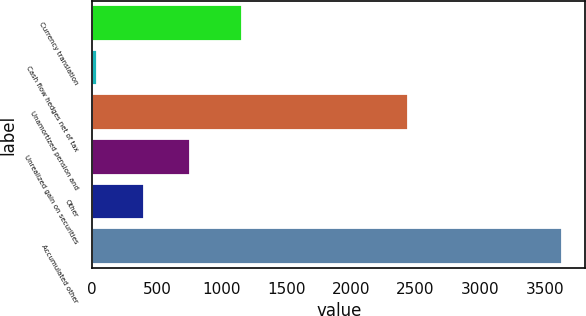<chart> <loc_0><loc_0><loc_500><loc_500><bar_chart><fcel>Currency translation<fcel>Cash flow hedges net of tax<fcel>Unamortized pension and<fcel>Unrealized gain on securities<fcel>Other<fcel>Accumulated other<nl><fcel>1159<fcel>38<fcel>2442<fcel>756.4<fcel>397.2<fcel>3630<nl></chart> 